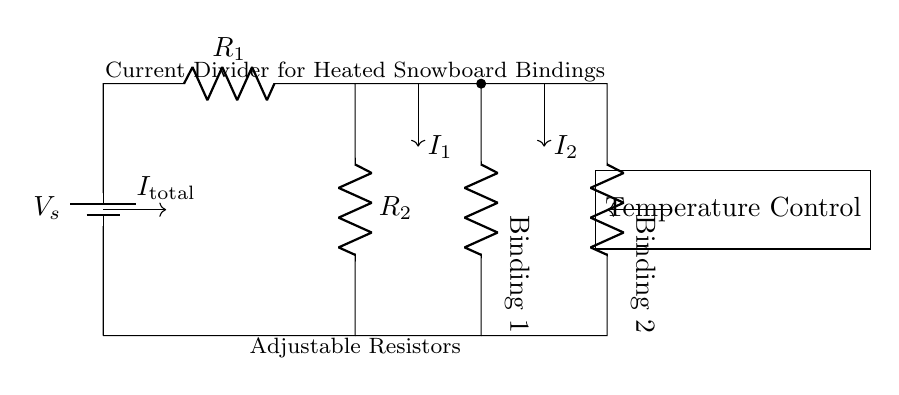What are the two resistors in the circuit? The two resistors in the circuit are labeled as R1 and R2. They are connected in parallel and represent the heated snowboard bindings.
Answer: R1, R2 What happens to the total current when one binding is turned off? When one binding is turned off, the total current will be reduced. In a parallel circuit, if one branch has infinite resistance (off), the current will flow only through the other branch, therefore decreasing the total current.
Answer: Decreases How is the current divided between the bindings? The current is divided based on the resistance values of each binding. According to the current divider rule, the current through each resistor is inversely proportional to its resistance.
Answer: Inversely proportional What is the function of the adjustable resistors? The adjustable resistors are used to set the desired temperature for each heated binding by varying the resistance. Adjusting these resistors changes how much current flows through each binding.
Answer: Temperature control What is the significance of the temperature control box in the circuit? The temperature control box allows the user to adjust the settings for the heated snowboard bindings, thus controlling the temperature independently for each binding.
Answer: Adjustable temperature settings What is the total current represented in the circuit? The total current is represented by \( I_\text{total} \) and it flows into the circuit from the battery. It will split between R1 and R2 based on their resistances.
Answer: I_total 